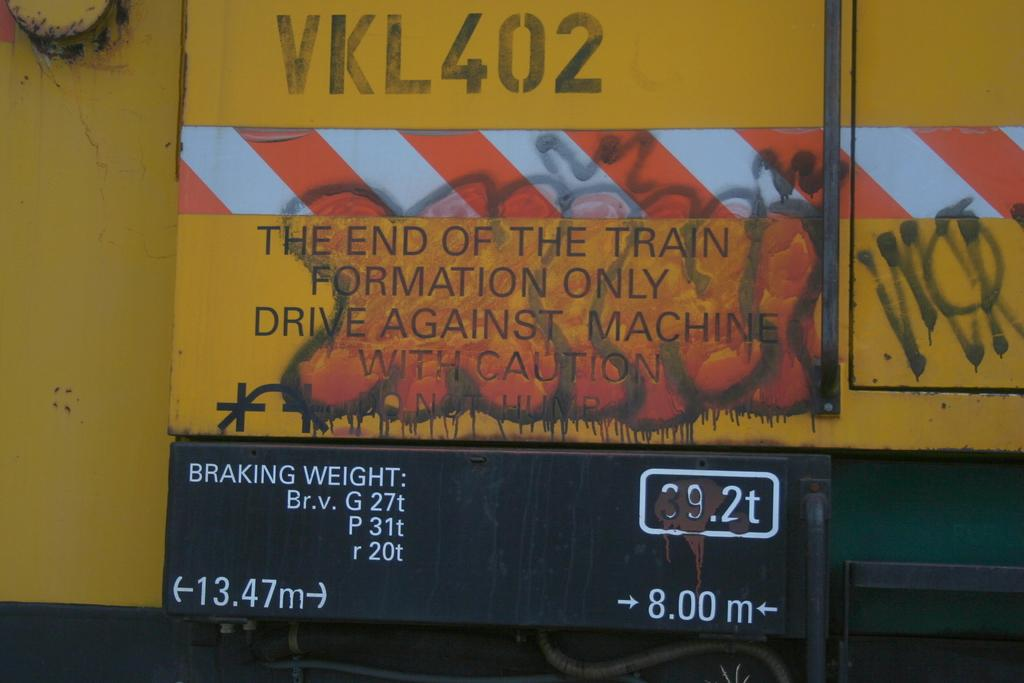<image>
Write a terse but informative summary of the picture. A sign with VKL402 is displayed on the end of a train. 